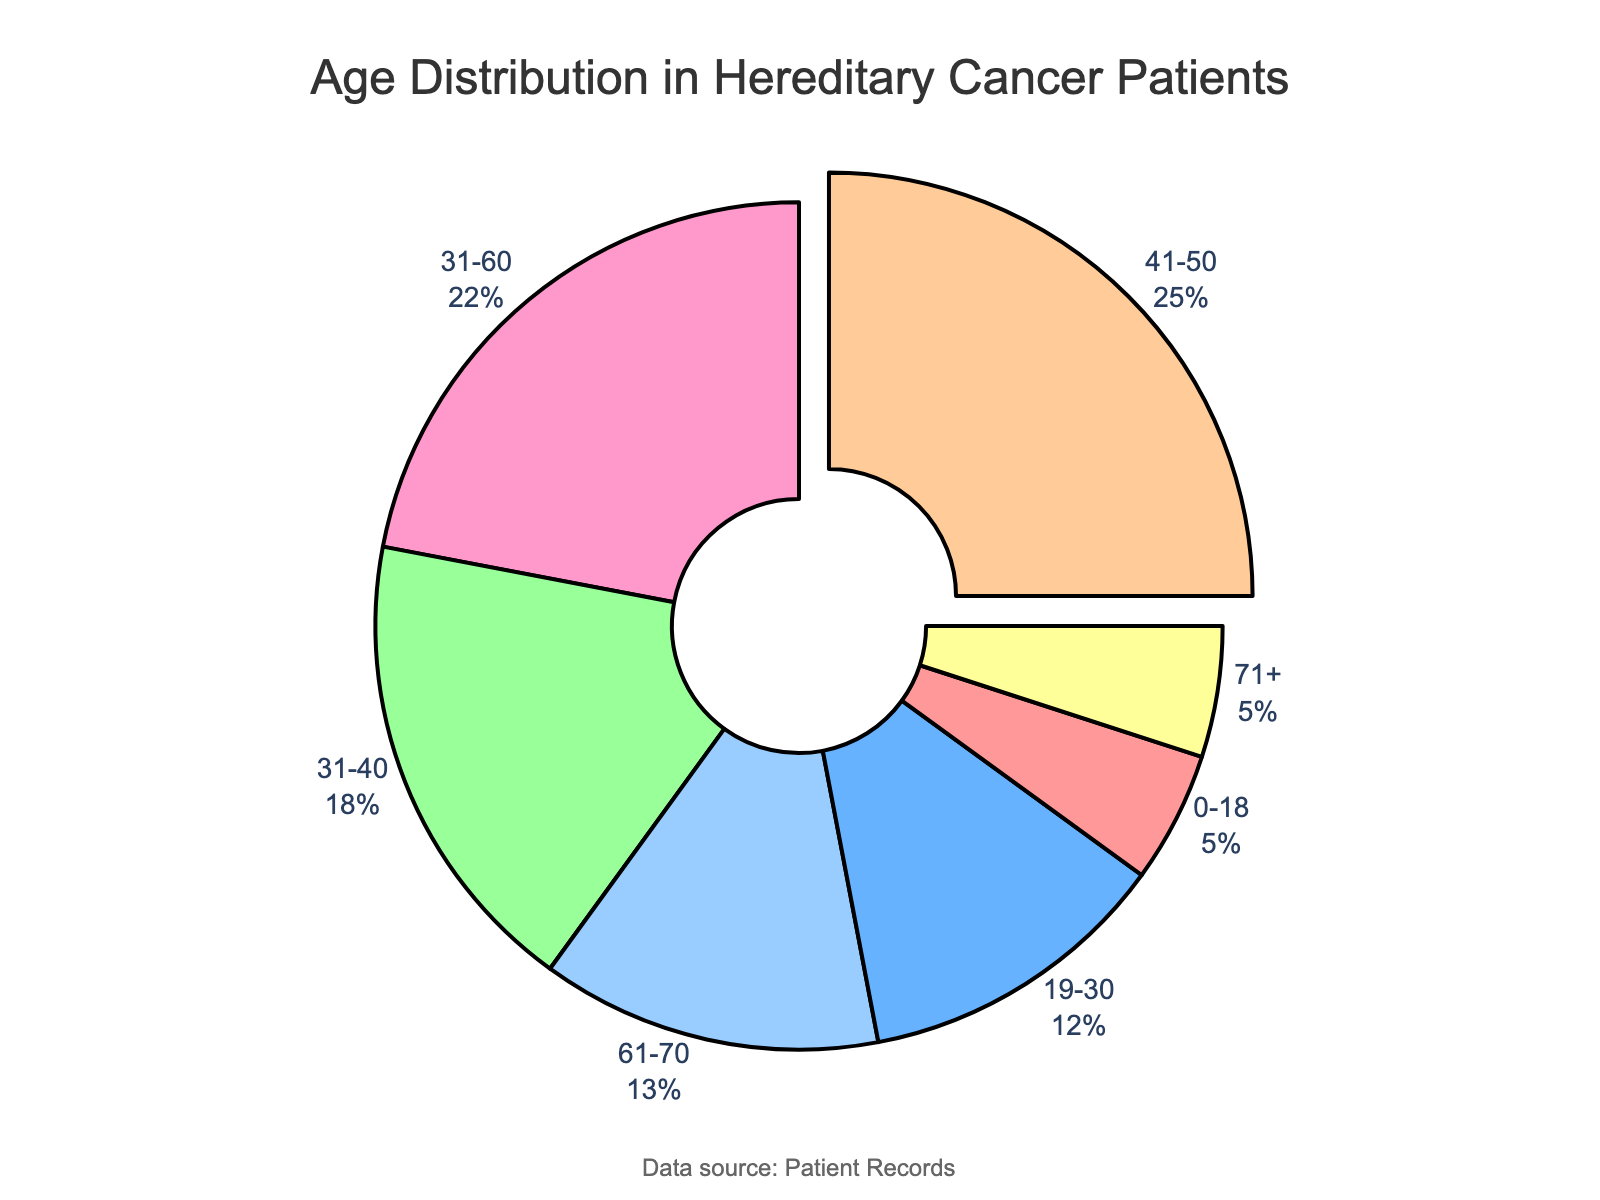Which age group has the highest percentage of affected individuals? The pie chart visually indicates that the age group 41-50 has a segment pulled out and the largest size, representing the highest percentage.
Answer: 41-50 How many age groups have a percentage of affected individuals greater than 10%? From the chart, the age groups with percentages greater than 10% are 19-30, 31-40, 41-50, 31-60, and 61-70. Counting these gives 5 groups.
Answer: 5 What percentage of affected individuals are aged 0-18 or 71+? The percentage for 0-18 is 5% and for 71+ is 5%. Adding these together gives 5% + 5% = 10%.
Answer: 10% Which age group has a smaller percentage of affected individuals, 19-30 or 61-70? From the pie chart, 61-70 has 13%, and 19-30 has 12%. Thus, the age group 19-30 has a smaller percentage.
Answer: 19-30 What is the difference in percentage between the age groups 31-40 and 41-50? The pie chart shows that 31-40 has 18% and 41-50 has 25%. The difference is calculated as 25% - 18% = 7%.
Answer: 7% Which age group has a percentage closer to 20%: 31-40 or 31-60? From the chart, the percentage for 31-40 is 18% and for 31-60 is 22%. Comparing the difference from 20%, 31-40 is 2% away, and 31-60 is 2% away. Both are equally close to 20%.
Answer: Both What is the average percentage of the four youngest age groups combined (0-18, 19-30, 31-40, 41-50)? Adding the percentages: 5% + 12% + 18% + 25% = 60%. Dividing by four groups gives 60% / 4 = 15%.
Answer: 15% Which two age groups together make up more than 40% of the affected individuals? The groups 41-50 and 31-60 have percentages of 25% and 22%, respectively. Together they sum to 47% which is greater than 40%.
Answer: 41-50 and 31-60 What color represents the age group 61-70 in the pie chart? The pie chart uses visually distinguishable colors. The segment for 61-70 is represented by a dark blue color.
Answer: Dark blue 